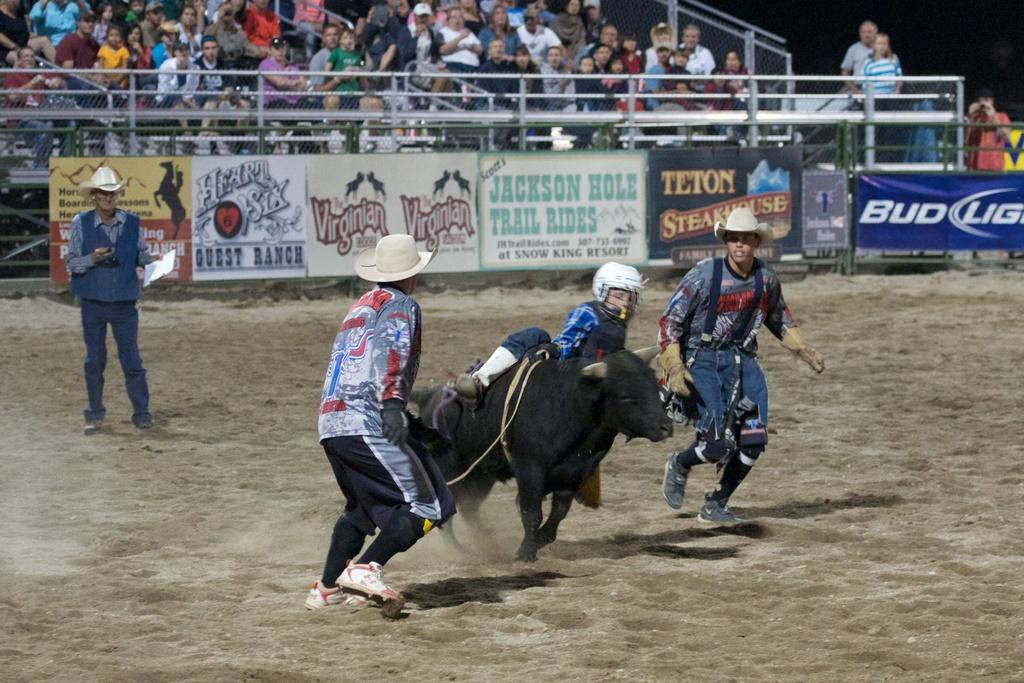How would you summarize this image in a sentence or two? In this picture we can see a person riding a bull, there are three persons standing, at the bottom there is sand, in the background there are some people sitting, we can see hoardings here, this person wore a helmet. 